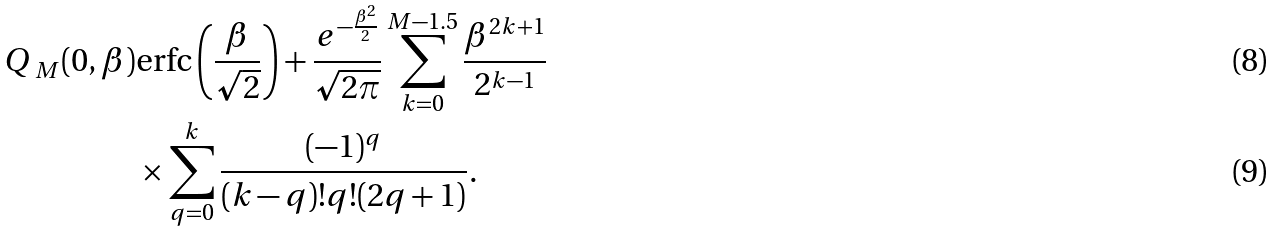<formula> <loc_0><loc_0><loc_500><loc_500>\emph { Q } _ { M } ( 0 , \beta ) & \text {erfc} \left ( \frac { \beta } { \sqrt { 2 } } \right ) + \frac { e ^ { - \frac { \beta ^ { 2 } } { 2 } } } { \sqrt { 2 \pi } } \sum _ { k = 0 } ^ { M - 1 . 5 } \frac { \beta ^ { 2 k + 1 } } { 2 ^ { k - 1 } } \\ & \times \sum _ { q = 0 } ^ { k } \frac { ( - 1 ) ^ { q } } { ( k - q ) ! q ! ( 2 q + 1 ) } .</formula> 